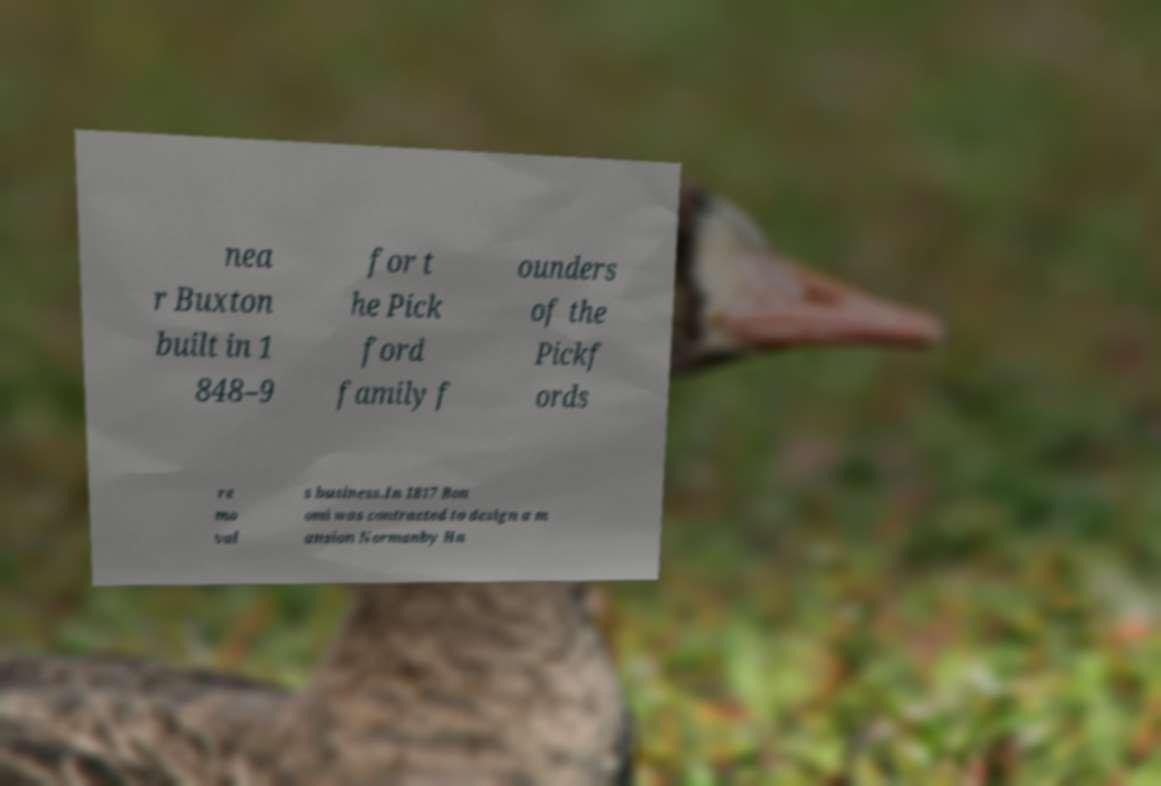For documentation purposes, I need the text within this image transcribed. Could you provide that? nea r Buxton built in 1 848–9 for t he Pick ford family f ounders of the Pickf ords re mo val s business.In 1817 Bon omi was contracted to design a m ansion Normanby Ha 